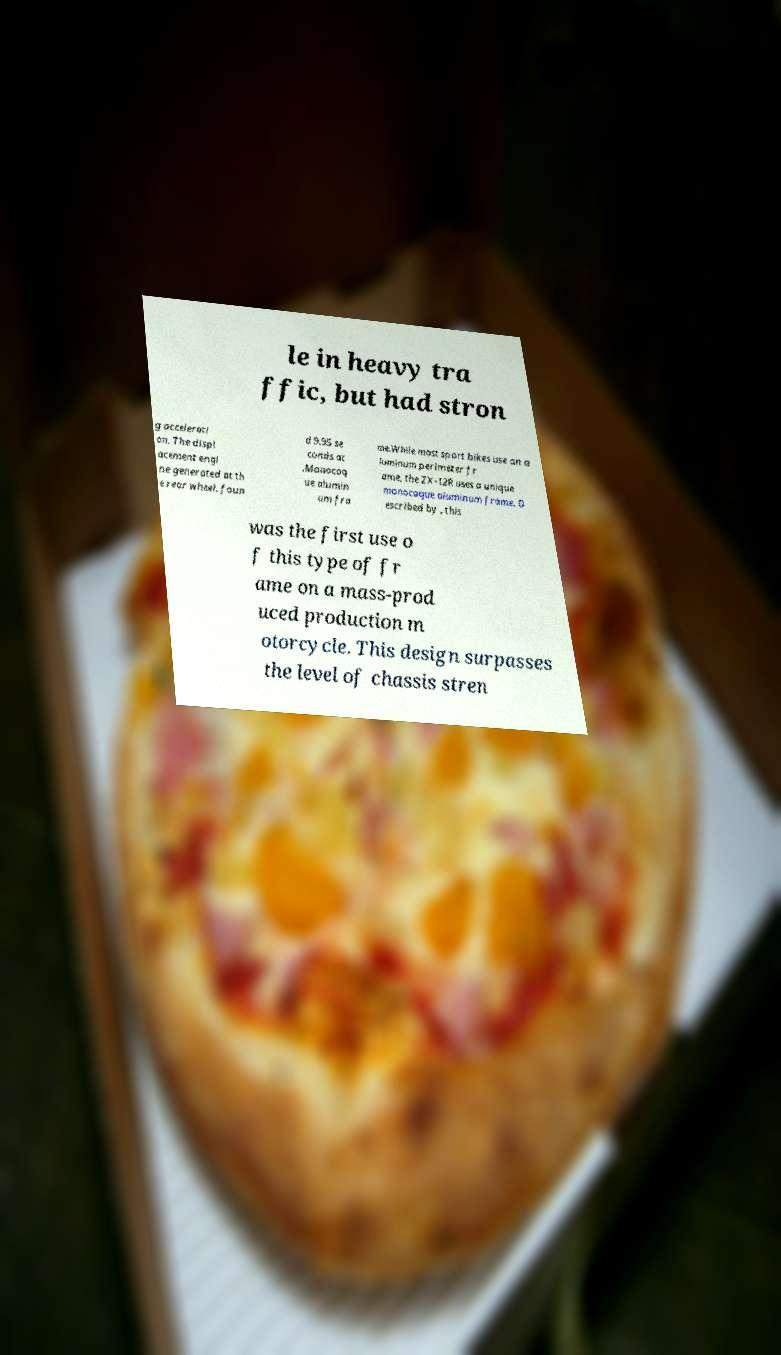Please identify and transcribe the text found in this image. le in heavy tra ffic, but had stron g accelerati on. The displ acement engi ne generated at th e rear wheel. foun d 9.95 se conds at .Monocoq ue alumin um fra me.While most sport bikes use an a luminum perimeter fr ame, the ZX-12R uses a unique monocoque aluminum frame. D escribed by , this was the first use o f this type of fr ame on a mass-prod uced production m otorcycle. This design surpasses the level of chassis stren 